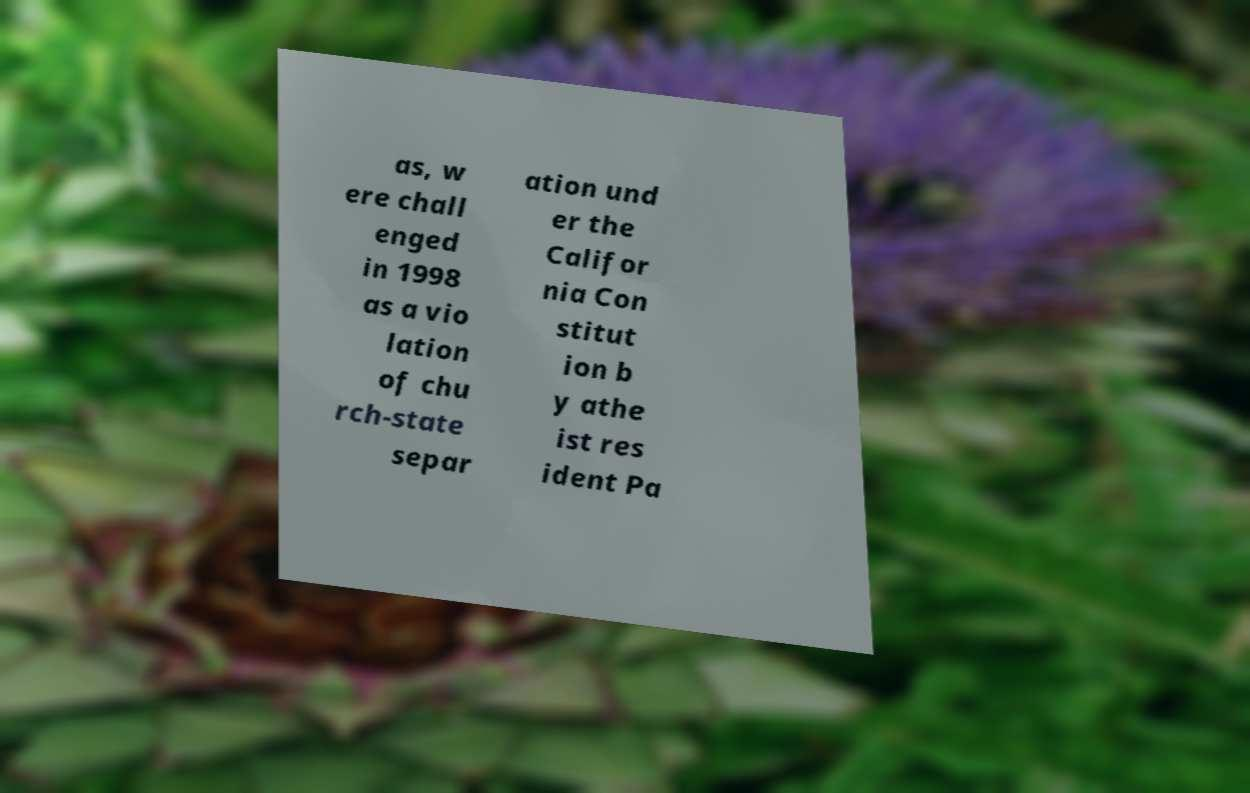Please read and relay the text visible in this image. What does it say? as, w ere chall enged in 1998 as a vio lation of chu rch-state separ ation und er the Califor nia Con stitut ion b y athe ist res ident Pa 